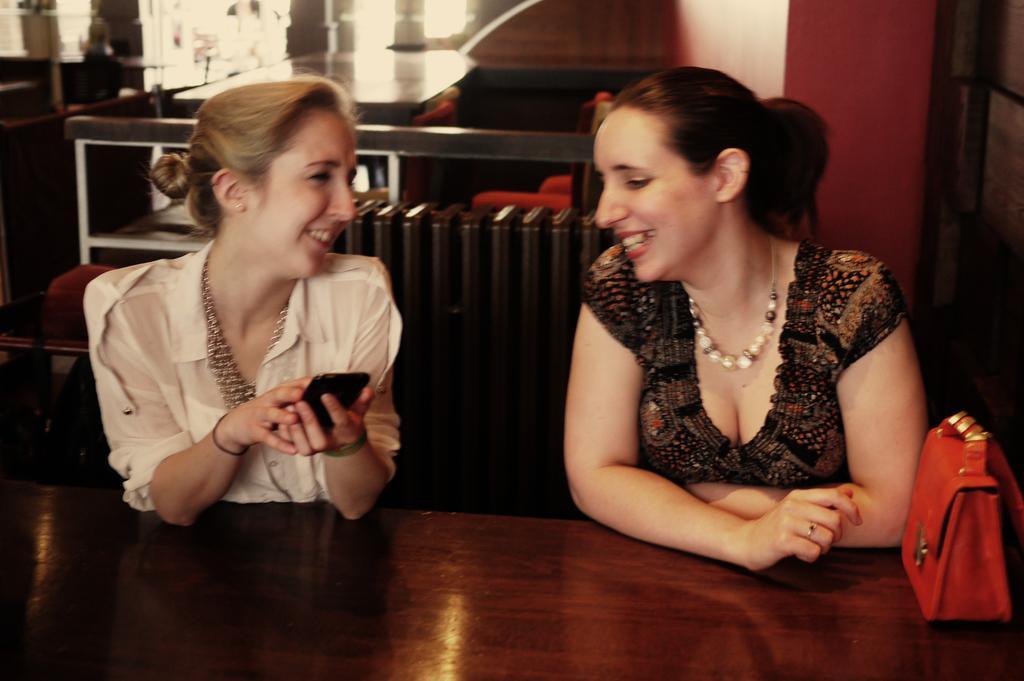Can you describe this image briefly? In this image there are two women who are talking with each other. The woman to the left side is holding a phone in her hand. There is a table in front of them on which there is a hand bag. At the background there is a wall. 